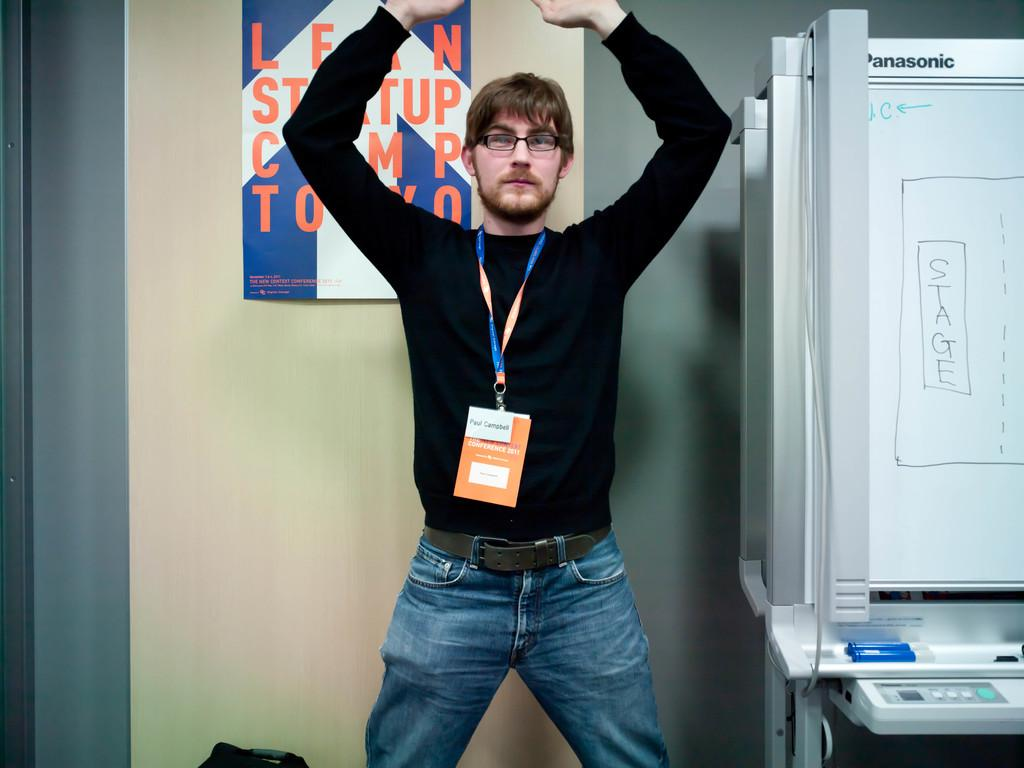<image>
Give a short and clear explanation of the subsequent image. A man in a black top and jeans wearing a name tag that says Paul Cmpbell. 